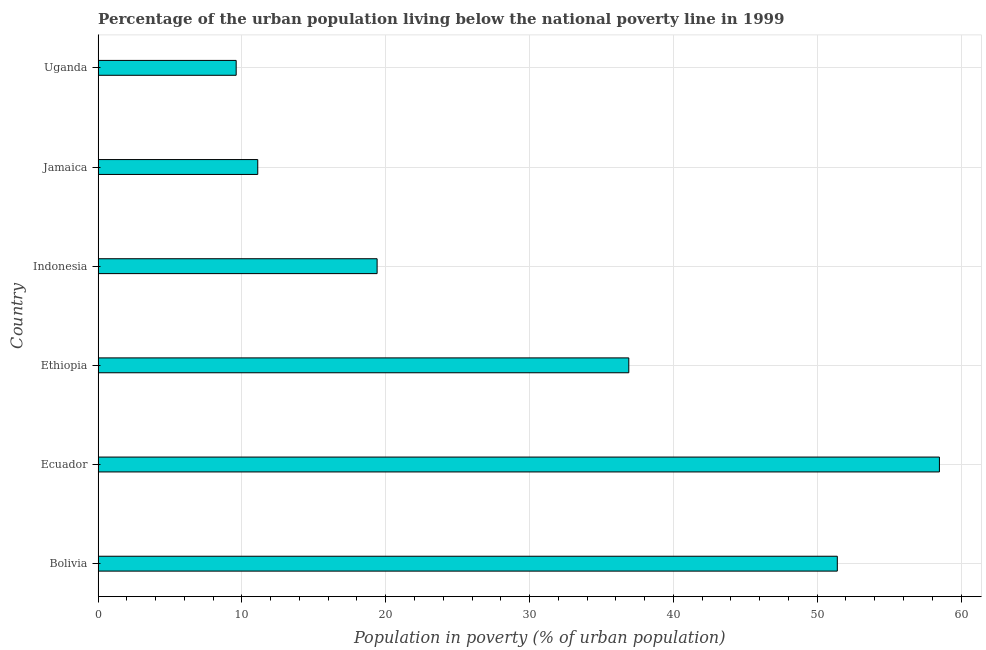What is the title of the graph?
Offer a terse response. Percentage of the urban population living below the national poverty line in 1999. What is the label or title of the X-axis?
Ensure brevity in your answer.  Population in poverty (% of urban population). What is the percentage of urban population living below poverty line in Ecuador?
Ensure brevity in your answer.  58.5. Across all countries, what is the maximum percentage of urban population living below poverty line?
Your answer should be very brief. 58.5. Across all countries, what is the minimum percentage of urban population living below poverty line?
Your answer should be very brief. 9.6. In which country was the percentage of urban population living below poverty line maximum?
Your response must be concise. Ecuador. In which country was the percentage of urban population living below poverty line minimum?
Provide a succinct answer. Uganda. What is the sum of the percentage of urban population living below poverty line?
Your answer should be very brief. 186.9. What is the difference between the percentage of urban population living below poverty line in Bolivia and Jamaica?
Ensure brevity in your answer.  40.3. What is the average percentage of urban population living below poverty line per country?
Keep it short and to the point. 31.15. What is the median percentage of urban population living below poverty line?
Keep it short and to the point. 28.15. What is the ratio of the percentage of urban population living below poverty line in Bolivia to that in Jamaica?
Your response must be concise. 4.63. Is the percentage of urban population living below poverty line in Ecuador less than that in Jamaica?
Your answer should be compact. No. What is the difference between the highest and the second highest percentage of urban population living below poverty line?
Keep it short and to the point. 7.1. Is the sum of the percentage of urban population living below poverty line in Jamaica and Uganda greater than the maximum percentage of urban population living below poverty line across all countries?
Keep it short and to the point. No. What is the difference between the highest and the lowest percentage of urban population living below poverty line?
Offer a very short reply. 48.9. How many bars are there?
Offer a very short reply. 6. What is the difference between two consecutive major ticks on the X-axis?
Make the answer very short. 10. Are the values on the major ticks of X-axis written in scientific E-notation?
Your answer should be very brief. No. What is the Population in poverty (% of urban population) of Bolivia?
Your response must be concise. 51.4. What is the Population in poverty (% of urban population) in Ecuador?
Offer a very short reply. 58.5. What is the Population in poverty (% of urban population) of Ethiopia?
Provide a succinct answer. 36.9. What is the difference between the Population in poverty (% of urban population) in Bolivia and Ethiopia?
Your response must be concise. 14.5. What is the difference between the Population in poverty (% of urban population) in Bolivia and Indonesia?
Keep it short and to the point. 32. What is the difference between the Population in poverty (% of urban population) in Bolivia and Jamaica?
Give a very brief answer. 40.3. What is the difference between the Population in poverty (% of urban population) in Bolivia and Uganda?
Give a very brief answer. 41.8. What is the difference between the Population in poverty (% of urban population) in Ecuador and Ethiopia?
Your answer should be compact. 21.6. What is the difference between the Population in poverty (% of urban population) in Ecuador and Indonesia?
Offer a terse response. 39.1. What is the difference between the Population in poverty (% of urban population) in Ecuador and Jamaica?
Ensure brevity in your answer.  47.4. What is the difference between the Population in poverty (% of urban population) in Ecuador and Uganda?
Offer a terse response. 48.9. What is the difference between the Population in poverty (% of urban population) in Ethiopia and Indonesia?
Make the answer very short. 17.5. What is the difference between the Population in poverty (% of urban population) in Ethiopia and Jamaica?
Provide a short and direct response. 25.8. What is the difference between the Population in poverty (% of urban population) in Ethiopia and Uganda?
Your answer should be very brief. 27.3. What is the difference between the Population in poverty (% of urban population) in Indonesia and Jamaica?
Keep it short and to the point. 8.3. What is the difference between the Population in poverty (% of urban population) in Indonesia and Uganda?
Your answer should be compact. 9.8. What is the ratio of the Population in poverty (% of urban population) in Bolivia to that in Ecuador?
Your response must be concise. 0.88. What is the ratio of the Population in poverty (% of urban population) in Bolivia to that in Ethiopia?
Ensure brevity in your answer.  1.39. What is the ratio of the Population in poverty (% of urban population) in Bolivia to that in Indonesia?
Your answer should be very brief. 2.65. What is the ratio of the Population in poverty (% of urban population) in Bolivia to that in Jamaica?
Make the answer very short. 4.63. What is the ratio of the Population in poverty (% of urban population) in Bolivia to that in Uganda?
Offer a very short reply. 5.35. What is the ratio of the Population in poverty (% of urban population) in Ecuador to that in Ethiopia?
Ensure brevity in your answer.  1.58. What is the ratio of the Population in poverty (% of urban population) in Ecuador to that in Indonesia?
Your answer should be very brief. 3.02. What is the ratio of the Population in poverty (% of urban population) in Ecuador to that in Jamaica?
Ensure brevity in your answer.  5.27. What is the ratio of the Population in poverty (% of urban population) in Ecuador to that in Uganda?
Provide a succinct answer. 6.09. What is the ratio of the Population in poverty (% of urban population) in Ethiopia to that in Indonesia?
Your answer should be compact. 1.9. What is the ratio of the Population in poverty (% of urban population) in Ethiopia to that in Jamaica?
Provide a succinct answer. 3.32. What is the ratio of the Population in poverty (% of urban population) in Ethiopia to that in Uganda?
Your response must be concise. 3.84. What is the ratio of the Population in poverty (% of urban population) in Indonesia to that in Jamaica?
Your answer should be very brief. 1.75. What is the ratio of the Population in poverty (% of urban population) in Indonesia to that in Uganda?
Offer a very short reply. 2.02. What is the ratio of the Population in poverty (% of urban population) in Jamaica to that in Uganda?
Your answer should be compact. 1.16. 